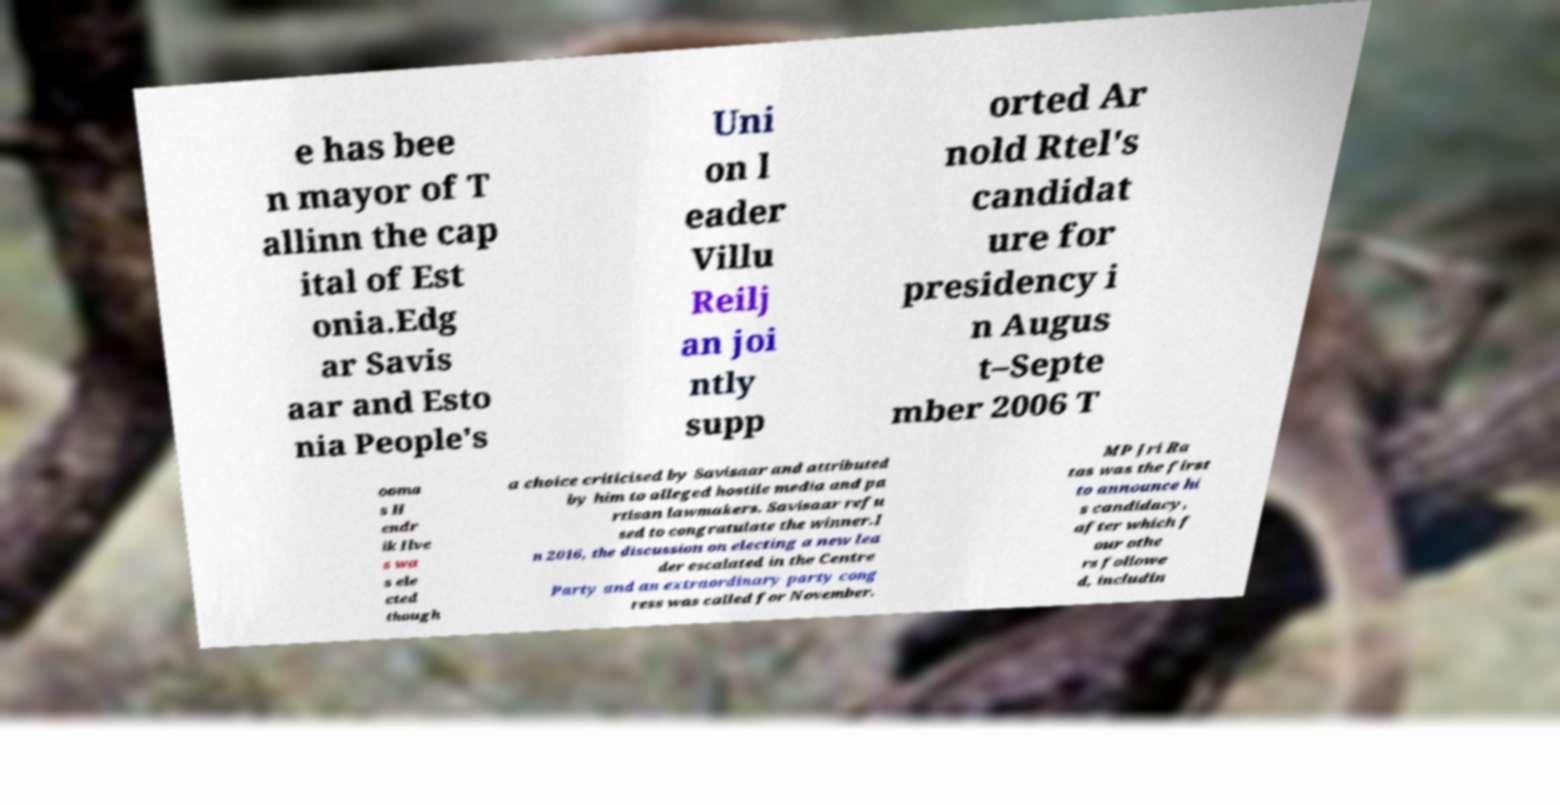Please identify and transcribe the text found in this image. e has bee n mayor of T allinn the cap ital of Est onia.Edg ar Savis aar and Esto nia People's Uni on l eader Villu Reilj an joi ntly supp orted Ar nold Rtel's candidat ure for presidency i n Augus t–Septe mber 2006 T ooma s H endr ik Ilve s wa s ele cted though a choice criticised by Savisaar and attributed by him to alleged hostile media and pa rtisan lawmakers. Savisaar refu sed to congratulate the winner.I n 2016, the discussion on electing a new lea der escalated in the Centre Party and an extraordinary party cong ress was called for November. MP Jri Ra tas was the first to announce hi s candidacy, after which f our othe rs followe d, includin 